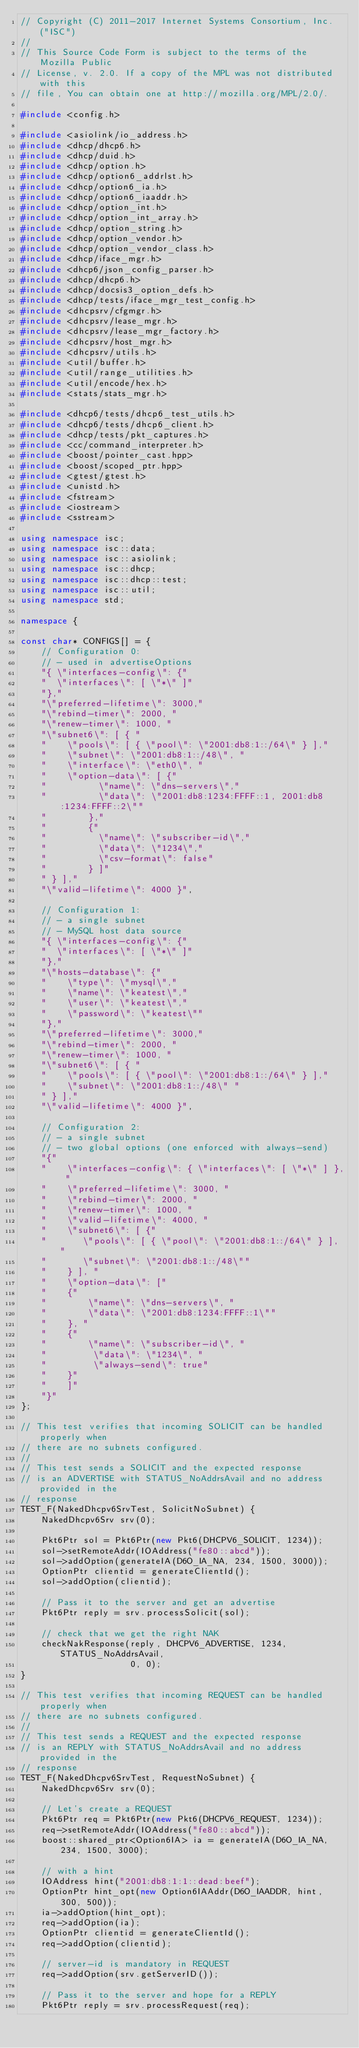<code> <loc_0><loc_0><loc_500><loc_500><_C++_>// Copyright (C) 2011-2017 Internet Systems Consortium, Inc. ("ISC")
//
// This Source Code Form is subject to the terms of the Mozilla Public
// License, v. 2.0. If a copy of the MPL was not distributed with this
// file, You can obtain one at http://mozilla.org/MPL/2.0/.

#include <config.h>

#include <asiolink/io_address.h>
#include <dhcp/dhcp6.h>
#include <dhcp/duid.h>
#include <dhcp/option.h>
#include <dhcp/option6_addrlst.h>
#include <dhcp/option6_ia.h>
#include <dhcp/option6_iaaddr.h>
#include <dhcp/option_int.h>
#include <dhcp/option_int_array.h>
#include <dhcp/option_string.h>
#include <dhcp/option_vendor.h>
#include <dhcp/option_vendor_class.h>
#include <dhcp/iface_mgr.h>
#include <dhcp6/json_config_parser.h>
#include <dhcp/dhcp6.h>
#include <dhcp/docsis3_option_defs.h>
#include <dhcp/tests/iface_mgr_test_config.h>
#include <dhcpsrv/cfgmgr.h>
#include <dhcpsrv/lease_mgr.h>
#include <dhcpsrv/lease_mgr_factory.h>
#include <dhcpsrv/host_mgr.h>
#include <dhcpsrv/utils.h>
#include <util/buffer.h>
#include <util/range_utilities.h>
#include <util/encode/hex.h>
#include <stats/stats_mgr.h>

#include <dhcp6/tests/dhcp6_test_utils.h>
#include <dhcp6/tests/dhcp6_client.h>
#include <dhcp/tests/pkt_captures.h>
#include <cc/command_interpreter.h>
#include <boost/pointer_cast.hpp>
#include <boost/scoped_ptr.hpp>
#include <gtest/gtest.h>
#include <unistd.h>
#include <fstream>
#include <iostream>
#include <sstream>

using namespace isc;
using namespace isc::data;
using namespace isc::asiolink;
using namespace isc::dhcp;
using namespace isc::dhcp::test;
using namespace isc::util;
using namespace std;

namespace {

const char* CONFIGS[] = {
    // Configuration 0:
    // - used in advertiseOptions
    "{ \"interfaces-config\": {"
    "  \"interfaces\": [ \"*\" ]"
    "},"
    "\"preferred-lifetime\": 3000,"
    "\"rebind-timer\": 2000, "
    "\"renew-timer\": 1000, "
    "\"subnet6\": [ { "
    "    \"pools\": [ { \"pool\": \"2001:db8:1::/64\" } ],"
    "    \"subnet\": \"2001:db8:1::/48\", "
    "    \"interface\": \"eth0\", "
    "    \"option-data\": [ {"
    "          \"name\": \"dns-servers\","
    "          \"data\": \"2001:db8:1234:FFFF::1, 2001:db8:1234:FFFF::2\""
    "        },"
    "        {"
    "          \"name\": \"subscriber-id\","
    "          \"data\": \"1234\","
    "          \"csv-format\": false"
    "        } ]"
    " } ],"
    "\"valid-lifetime\": 4000 }",

    // Configuration 1:
    // - a single subnet
    // - MySQL host data source
    "{ \"interfaces-config\": {"
    "  \"interfaces\": [ \"*\" ]"
    "},"
    "\"hosts-database\": {"
    "    \"type\": \"mysql\","
    "    \"name\": \"keatest\","
    "    \"user\": \"keatest\","
    "    \"password\": \"keatest\""
    "},"
    "\"preferred-lifetime\": 3000,"
    "\"rebind-timer\": 2000, "
    "\"renew-timer\": 1000, "
    "\"subnet6\": [ { "
    "    \"pools\": [ { \"pool\": \"2001:db8:1::/64\" } ],"
    "    \"subnet\": \"2001:db8:1::/48\" "
    " } ],"
    "\"valid-lifetime\": 4000 }",

    // Configuration 2:
    // - a single subnet
    // - two global options (one enforced with always-send)
    "{"
    "    \"interfaces-config\": { \"interfaces\": [ \"*\" ] }, "
    "    \"preferred-lifetime\": 3000, "
    "    \"rebind-timer\": 2000, "
    "    \"renew-timer\": 1000, "
    "    \"valid-lifetime\": 4000, "
    "    \"subnet6\": [ {"
    "       \"pools\": [ { \"pool\": \"2001:db8:1::/64\" } ], "
    "       \"subnet\": \"2001:db8:1::/48\""
    "    } ], "
    "    \"option-data\": ["
    "    {"
    "        \"name\": \"dns-servers\", "
    "        \"data\": \"2001:db8:1234:FFFF::1\""
    "    }, "
    "    {"
    "        \"name\": \"subscriber-id\", "
    "         \"data\": \"1234\", "
    "         \"always-send\": true"
    "    }"
    "    ]"
    "}"
};

// This test verifies that incoming SOLICIT can be handled properly when
// there are no subnets configured.
//
// This test sends a SOLICIT and the expected response
// is an ADVERTISE with STATUS_NoAddrsAvail and no address provided in the
// response
TEST_F(NakedDhcpv6SrvTest, SolicitNoSubnet) {
    NakedDhcpv6Srv srv(0);

    Pkt6Ptr sol = Pkt6Ptr(new Pkt6(DHCPV6_SOLICIT, 1234));
    sol->setRemoteAddr(IOAddress("fe80::abcd"));
    sol->addOption(generateIA(D6O_IA_NA, 234, 1500, 3000));
    OptionPtr clientid = generateClientId();
    sol->addOption(clientid);

    // Pass it to the server and get an advertise
    Pkt6Ptr reply = srv.processSolicit(sol);

    // check that we get the right NAK
    checkNakResponse(reply, DHCPV6_ADVERTISE, 1234, STATUS_NoAddrsAvail,
                     0, 0);
}

// This test verifies that incoming REQUEST can be handled properly when
// there are no subnets configured.
//
// This test sends a REQUEST and the expected response
// is an REPLY with STATUS_NoAddrsAvail and no address provided in the
// response
TEST_F(NakedDhcpv6SrvTest, RequestNoSubnet) {
    NakedDhcpv6Srv srv(0);

    // Let's create a REQUEST
    Pkt6Ptr req = Pkt6Ptr(new Pkt6(DHCPV6_REQUEST, 1234));
    req->setRemoteAddr(IOAddress("fe80::abcd"));
    boost::shared_ptr<Option6IA> ia = generateIA(D6O_IA_NA, 234, 1500, 3000);

    // with a hint
    IOAddress hint("2001:db8:1:1::dead:beef");
    OptionPtr hint_opt(new Option6IAAddr(D6O_IAADDR, hint, 300, 500));
    ia->addOption(hint_opt);
    req->addOption(ia);
    OptionPtr clientid = generateClientId();
    req->addOption(clientid);

    // server-id is mandatory in REQUEST
    req->addOption(srv.getServerID());

    // Pass it to the server and hope for a REPLY
    Pkt6Ptr reply = srv.processRequest(req);
</code> 